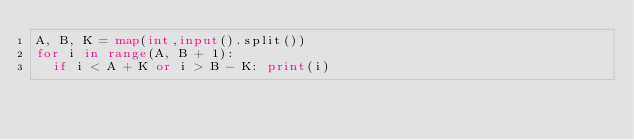<code> <loc_0><loc_0><loc_500><loc_500><_Python_>A, B, K = map(int,input().split())
for i in range(A, B + 1):
  if i < A + K or i > B - K: print(i) 
</code> 